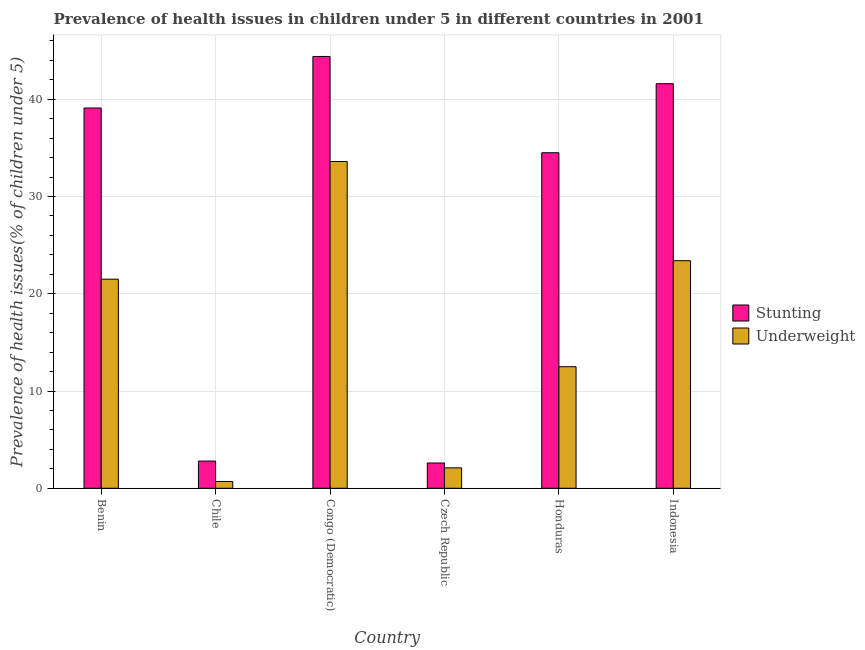How many different coloured bars are there?
Your answer should be compact. 2. How many groups of bars are there?
Give a very brief answer. 6. Are the number of bars per tick equal to the number of legend labels?
Offer a terse response. Yes. Are the number of bars on each tick of the X-axis equal?
Offer a terse response. Yes. How many bars are there on the 1st tick from the right?
Make the answer very short. 2. What is the label of the 6th group of bars from the left?
Offer a terse response. Indonesia. What is the percentage of underweight children in Indonesia?
Offer a very short reply. 23.4. Across all countries, what is the maximum percentage of underweight children?
Your answer should be compact. 33.6. Across all countries, what is the minimum percentage of underweight children?
Provide a succinct answer. 0.7. In which country was the percentage of stunted children maximum?
Keep it short and to the point. Congo (Democratic). In which country was the percentage of underweight children minimum?
Give a very brief answer. Chile. What is the total percentage of stunted children in the graph?
Your answer should be compact. 165. What is the difference between the percentage of stunted children in Benin and that in Czech Republic?
Provide a short and direct response. 36.5. What is the difference between the percentage of underweight children in Honduras and the percentage of stunted children in Congo (Democratic)?
Provide a short and direct response. -31.9. What is the average percentage of underweight children per country?
Your answer should be very brief. 15.63. What is the difference between the percentage of underweight children and percentage of stunted children in Congo (Democratic)?
Make the answer very short. -10.8. In how many countries, is the percentage of stunted children greater than 20 %?
Provide a short and direct response. 4. What is the ratio of the percentage of stunted children in Congo (Democratic) to that in Indonesia?
Offer a terse response. 1.07. Is the percentage of stunted children in Chile less than that in Czech Republic?
Offer a terse response. No. What is the difference between the highest and the second highest percentage of stunted children?
Offer a terse response. 2.8. What is the difference between the highest and the lowest percentage of underweight children?
Your response must be concise. 32.9. What does the 2nd bar from the left in Congo (Democratic) represents?
Give a very brief answer. Underweight. What does the 1st bar from the right in Czech Republic represents?
Provide a succinct answer. Underweight. How many bars are there?
Your response must be concise. 12. Are all the bars in the graph horizontal?
Your answer should be very brief. No. How many countries are there in the graph?
Your answer should be compact. 6. Does the graph contain any zero values?
Provide a short and direct response. No. Does the graph contain grids?
Provide a succinct answer. Yes. What is the title of the graph?
Keep it short and to the point. Prevalence of health issues in children under 5 in different countries in 2001. What is the label or title of the Y-axis?
Your response must be concise. Prevalence of health issues(% of children under 5). What is the Prevalence of health issues(% of children under 5) in Stunting in Benin?
Ensure brevity in your answer.  39.1. What is the Prevalence of health issues(% of children under 5) in Underweight in Benin?
Ensure brevity in your answer.  21.5. What is the Prevalence of health issues(% of children under 5) of Stunting in Chile?
Provide a short and direct response. 2.8. What is the Prevalence of health issues(% of children under 5) of Underweight in Chile?
Give a very brief answer. 0.7. What is the Prevalence of health issues(% of children under 5) of Stunting in Congo (Democratic)?
Your response must be concise. 44.4. What is the Prevalence of health issues(% of children under 5) of Underweight in Congo (Democratic)?
Your answer should be very brief. 33.6. What is the Prevalence of health issues(% of children under 5) in Stunting in Czech Republic?
Provide a short and direct response. 2.6. What is the Prevalence of health issues(% of children under 5) in Underweight in Czech Republic?
Your answer should be very brief. 2.1. What is the Prevalence of health issues(% of children under 5) of Stunting in Honduras?
Offer a terse response. 34.5. What is the Prevalence of health issues(% of children under 5) in Stunting in Indonesia?
Keep it short and to the point. 41.6. What is the Prevalence of health issues(% of children under 5) of Underweight in Indonesia?
Provide a succinct answer. 23.4. Across all countries, what is the maximum Prevalence of health issues(% of children under 5) in Stunting?
Your answer should be compact. 44.4. Across all countries, what is the maximum Prevalence of health issues(% of children under 5) of Underweight?
Provide a succinct answer. 33.6. Across all countries, what is the minimum Prevalence of health issues(% of children under 5) in Stunting?
Your response must be concise. 2.6. Across all countries, what is the minimum Prevalence of health issues(% of children under 5) in Underweight?
Provide a succinct answer. 0.7. What is the total Prevalence of health issues(% of children under 5) of Stunting in the graph?
Your answer should be very brief. 165. What is the total Prevalence of health issues(% of children under 5) in Underweight in the graph?
Keep it short and to the point. 93.8. What is the difference between the Prevalence of health issues(% of children under 5) in Stunting in Benin and that in Chile?
Offer a very short reply. 36.3. What is the difference between the Prevalence of health issues(% of children under 5) in Underweight in Benin and that in Chile?
Provide a succinct answer. 20.8. What is the difference between the Prevalence of health issues(% of children under 5) of Stunting in Benin and that in Czech Republic?
Offer a terse response. 36.5. What is the difference between the Prevalence of health issues(% of children under 5) of Stunting in Benin and that in Honduras?
Give a very brief answer. 4.6. What is the difference between the Prevalence of health issues(% of children under 5) of Underweight in Benin and that in Honduras?
Your answer should be very brief. 9. What is the difference between the Prevalence of health issues(% of children under 5) in Stunting in Benin and that in Indonesia?
Offer a very short reply. -2.5. What is the difference between the Prevalence of health issues(% of children under 5) in Stunting in Chile and that in Congo (Democratic)?
Make the answer very short. -41.6. What is the difference between the Prevalence of health issues(% of children under 5) of Underweight in Chile and that in Congo (Democratic)?
Your response must be concise. -32.9. What is the difference between the Prevalence of health issues(% of children under 5) of Stunting in Chile and that in Czech Republic?
Make the answer very short. 0.2. What is the difference between the Prevalence of health issues(% of children under 5) in Stunting in Chile and that in Honduras?
Keep it short and to the point. -31.7. What is the difference between the Prevalence of health issues(% of children under 5) in Stunting in Chile and that in Indonesia?
Provide a short and direct response. -38.8. What is the difference between the Prevalence of health issues(% of children under 5) in Underweight in Chile and that in Indonesia?
Your response must be concise. -22.7. What is the difference between the Prevalence of health issues(% of children under 5) in Stunting in Congo (Democratic) and that in Czech Republic?
Provide a succinct answer. 41.8. What is the difference between the Prevalence of health issues(% of children under 5) of Underweight in Congo (Democratic) and that in Czech Republic?
Make the answer very short. 31.5. What is the difference between the Prevalence of health issues(% of children under 5) of Underweight in Congo (Democratic) and that in Honduras?
Give a very brief answer. 21.1. What is the difference between the Prevalence of health issues(% of children under 5) of Stunting in Czech Republic and that in Honduras?
Give a very brief answer. -31.9. What is the difference between the Prevalence of health issues(% of children under 5) in Underweight in Czech Republic and that in Honduras?
Give a very brief answer. -10.4. What is the difference between the Prevalence of health issues(% of children under 5) in Stunting in Czech Republic and that in Indonesia?
Your answer should be very brief. -39. What is the difference between the Prevalence of health issues(% of children under 5) of Underweight in Czech Republic and that in Indonesia?
Your answer should be compact. -21.3. What is the difference between the Prevalence of health issues(% of children under 5) in Underweight in Honduras and that in Indonesia?
Offer a very short reply. -10.9. What is the difference between the Prevalence of health issues(% of children under 5) in Stunting in Benin and the Prevalence of health issues(% of children under 5) in Underweight in Chile?
Make the answer very short. 38.4. What is the difference between the Prevalence of health issues(% of children under 5) of Stunting in Benin and the Prevalence of health issues(% of children under 5) of Underweight in Congo (Democratic)?
Provide a short and direct response. 5.5. What is the difference between the Prevalence of health issues(% of children under 5) of Stunting in Benin and the Prevalence of health issues(% of children under 5) of Underweight in Honduras?
Provide a succinct answer. 26.6. What is the difference between the Prevalence of health issues(% of children under 5) of Stunting in Benin and the Prevalence of health issues(% of children under 5) of Underweight in Indonesia?
Offer a very short reply. 15.7. What is the difference between the Prevalence of health issues(% of children under 5) in Stunting in Chile and the Prevalence of health issues(% of children under 5) in Underweight in Congo (Democratic)?
Provide a short and direct response. -30.8. What is the difference between the Prevalence of health issues(% of children under 5) in Stunting in Chile and the Prevalence of health issues(% of children under 5) in Underweight in Czech Republic?
Provide a succinct answer. 0.7. What is the difference between the Prevalence of health issues(% of children under 5) in Stunting in Chile and the Prevalence of health issues(% of children under 5) in Underweight in Honduras?
Your answer should be very brief. -9.7. What is the difference between the Prevalence of health issues(% of children under 5) in Stunting in Chile and the Prevalence of health issues(% of children under 5) in Underweight in Indonesia?
Make the answer very short. -20.6. What is the difference between the Prevalence of health issues(% of children under 5) of Stunting in Congo (Democratic) and the Prevalence of health issues(% of children under 5) of Underweight in Czech Republic?
Your response must be concise. 42.3. What is the difference between the Prevalence of health issues(% of children under 5) in Stunting in Congo (Democratic) and the Prevalence of health issues(% of children under 5) in Underweight in Honduras?
Provide a short and direct response. 31.9. What is the difference between the Prevalence of health issues(% of children under 5) of Stunting in Congo (Democratic) and the Prevalence of health issues(% of children under 5) of Underweight in Indonesia?
Make the answer very short. 21. What is the difference between the Prevalence of health issues(% of children under 5) in Stunting in Czech Republic and the Prevalence of health issues(% of children under 5) in Underweight in Honduras?
Provide a short and direct response. -9.9. What is the difference between the Prevalence of health issues(% of children under 5) in Stunting in Czech Republic and the Prevalence of health issues(% of children under 5) in Underweight in Indonesia?
Give a very brief answer. -20.8. What is the average Prevalence of health issues(% of children under 5) in Underweight per country?
Your answer should be compact. 15.63. What is the difference between the Prevalence of health issues(% of children under 5) in Stunting and Prevalence of health issues(% of children under 5) in Underweight in Benin?
Make the answer very short. 17.6. What is the difference between the Prevalence of health issues(% of children under 5) of Stunting and Prevalence of health issues(% of children under 5) of Underweight in Chile?
Make the answer very short. 2.1. What is the difference between the Prevalence of health issues(% of children under 5) of Stunting and Prevalence of health issues(% of children under 5) of Underweight in Congo (Democratic)?
Your answer should be very brief. 10.8. What is the difference between the Prevalence of health issues(% of children under 5) of Stunting and Prevalence of health issues(% of children under 5) of Underweight in Czech Republic?
Give a very brief answer. 0.5. What is the difference between the Prevalence of health issues(% of children under 5) in Stunting and Prevalence of health issues(% of children under 5) in Underweight in Honduras?
Provide a succinct answer. 22. What is the difference between the Prevalence of health issues(% of children under 5) in Stunting and Prevalence of health issues(% of children under 5) in Underweight in Indonesia?
Give a very brief answer. 18.2. What is the ratio of the Prevalence of health issues(% of children under 5) of Stunting in Benin to that in Chile?
Provide a short and direct response. 13.96. What is the ratio of the Prevalence of health issues(% of children under 5) in Underweight in Benin to that in Chile?
Your answer should be compact. 30.71. What is the ratio of the Prevalence of health issues(% of children under 5) of Stunting in Benin to that in Congo (Democratic)?
Provide a succinct answer. 0.88. What is the ratio of the Prevalence of health issues(% of children under 5) of Underweight in Benin to that in Congo (Democratic)?
Keep it short and to the point. 0.64. What is the ratio of the Prevalence of health issues(% of children under 5) of Stunting in Benin to that in Czech Republic?
Make the answer very short. 15.04. What is the ratio of the Prevalence of health issues(% of children under 5) in Underweight in Benin to that in Czech Republic?
Offer a very short reply. 10.24. What is the ratio of the Prevalence of health issues(% of children under 5) of Stunting in Benin to that in Honduras?
Give a very brief answer. 1.13. What is the ratio of the Prevalence of health issues(% of children under 5) in Underweight in Benin to that in Honduras?
Your answer should be very brief. 1.72. What is the ratio of the Prevalence of health issues(% of children under 5) of Stunting in Benin to that in Indonesia?
Give a very brief answer. 0.94. What is the ratio of the Prevalence of health issues(% of children under 5) of Underweight in Benin to that in Indonesia?
Provide a short and direct response. 0.92. What is the ratio of the Prevalence of health issues(% of children under 5) in Stunting in Chile to that in Congo (Democratic)?
Make the answer very short. 0.06. What is the ratio of the Prevalence of health issues(% of children under 5) in Underweight in Chile to that in Congo (Democratic)?
Provide a short and direct response. 0.02. What is the ratio of the Prevalence of health issues(% of children under 5) of Underweight in Chile to that in Czech Republic?
Offer a terse response. 0.33. What is the ratio of the Prevalence of health issues(% of children under 5) of Stunting in Chile to that in Honduras?
Make the answer very short. 0.08. What is the ratio of the Prevalence of health issues(% of children under 5) in Underweight in Chile to that in Honduras?
Give a very brief answer. 0.06. What is the ratio of the Prevalence of health issues(% of children under 5) in Stunting in Chile to that in Indonesia?
Your answer should be very brief. 0.07. What is the ratio of the Prevalence of health issues(% of children under 5) of Underweight in Chile to that in Indonesia?
Your answer should be very brief. 0.03. What is the ratio of the Prevalence of health issues(% of children under 5) in Stunting in Congo (Democratic) to that in Czech Republic?
Make the answer very short. 17.08. What is the ratio of the Prevalence of health issues(% of children under 5) in Underweight in Congo (Democratic) to that in Czech Republic?
Ensure brevity in your answer.  16. What is the ratio of the Prevalence of health issues(% of children under 5) of Stunting in Congo (Democratic) to that in Honduras?
Your response must be concise. 1.29. What is the ratio of the Prevalence of health issues(% of children under 5) in Underweight in Congo (Democratic) to that in Honduras?
Make the answer very short. 2.69. What is the ratio of the Prevalence of health issues(% of children under 5) in Stunting in Congo (Democratic) to that in Indonesia?
Your answer should be very brief. 1.07. What is the ratio of the Prevalence of health issues(% of children under 5) in Underweight in Congo (Democratic) to that in Indonesia?
Your response must be concise. 1.44. What is the ratio of the Prevalence of health issues(% of children under 5) of Stunting in Czech Republic to that in Honduras?
Provide a succinct answer. 0.08. What is the ratio of the Prevalence of health issues(% of children under 5) of Underweight in Czech Republic to that in Honduras?
Give a very brief answer. 0.17. What is the ratio of the Prevalence of health issues(% of children under 5) of Stunting in Czech Republic to that in Indonesia?
Offer a very short reply. 0.06. What is the ratio of the Prevalence of health issues(% of children under 5) in Underweight in Czech Republic to that in Indonesia?
Your answer should be very brief. 0.09. What is the ratio of the Prevalence of health issues(% of children under 5) of Stunting in Honduras to that in Indonesia?
Provide a succinct answer. 0.83. What is the ratio of the Prevalence of health issues(% of children under 5) in Underweight in Honduras to that in Indonesia?
Your answer should be compact. 0.53. What is the difference between the highest and the second highest Prevalence of health issues(% of children under 5) in Stunting?
Your answer should be compact. 2.8. What is the difference between the highest and the second highest Prevalence of health issues(% of children under 5) of Underweight?
Offer a very short reply. 10.2. What is the difference between the highest and the lowest Prevalence of health issues(% of children under 5) of Stunting?
Provide a succinct answer. 41.8. What is the difference between the highest and the lowest Prevalence of health issues(% of children under 5) in Underweight?
Give a very brief answer. 32.9. 